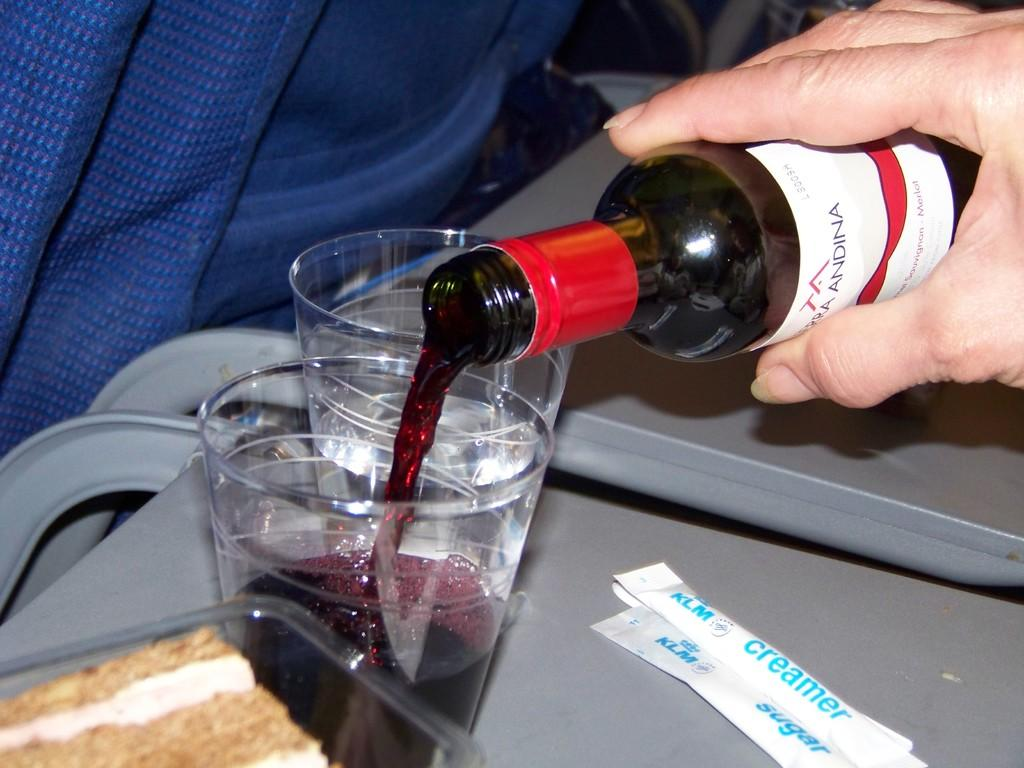<image>
Relay a brief, clear account of the picture shown. A small bottle of wine with Andina visible on the label is being poured into a glass. 